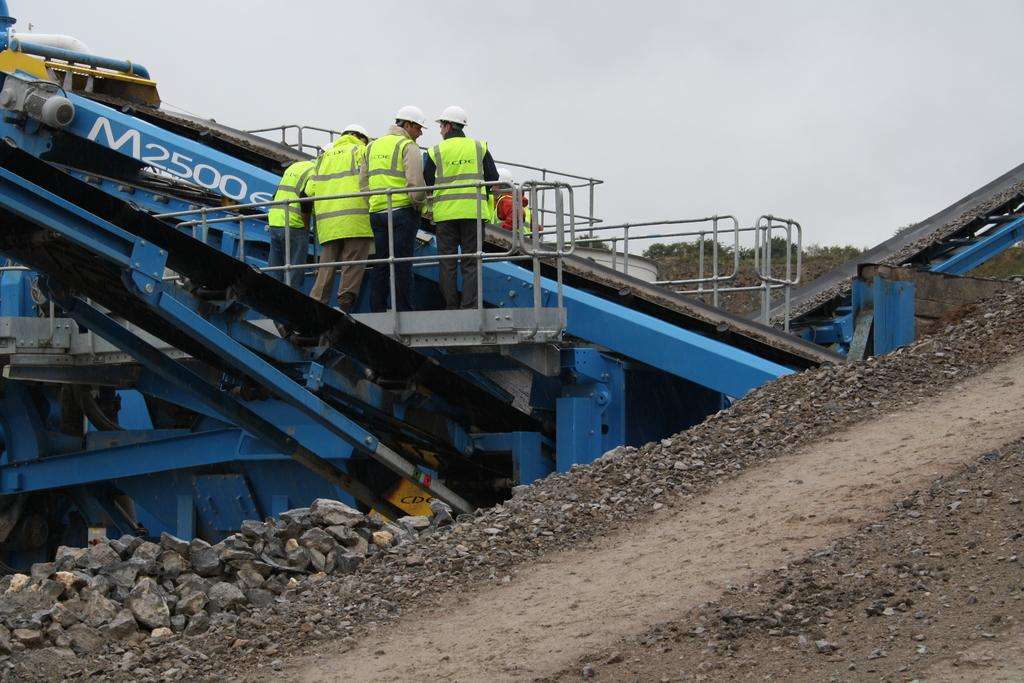<image>
Offer a succinct explanation of the picture presented. A piece of equipment has M2500 in white letters. 